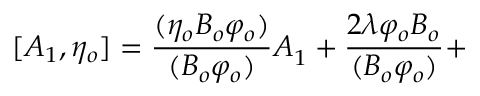Convert formula to latex. <formula><loc_0><loc_0><loc_500><loc_500>[ A _ { 1 } , \eta _ { o } ] = \frac { ( \eta _ { o } B _ { o } \varphi _ { o } ) } { ( B _ { o } \varphi _ { o } ) } A _ { 1 } + \frac { 2 \lambda \varphi _ { o } B _ { o } } { ( B _ { o } \varphi _ { o } ) } +</formula> 